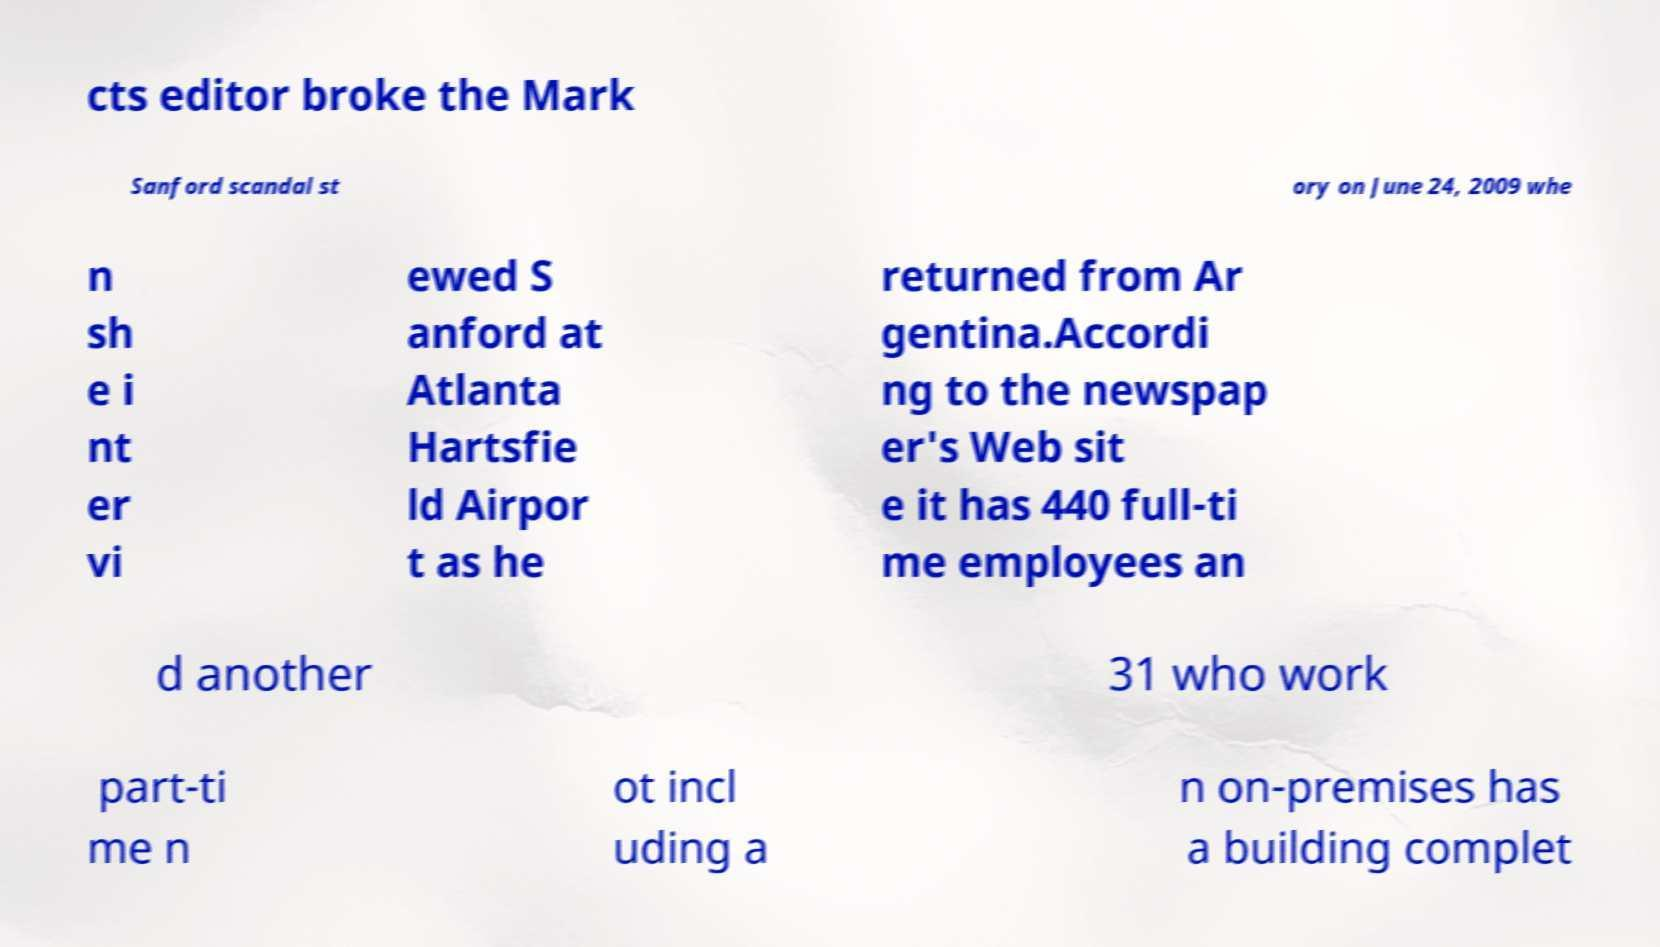Can you read and provide the text displayed in the image?This photo seems to have some interesting text. Can you extract and type it out for me? cts editor broke the Mark Sanford scandal st ory on June 24, 2009 whe n sh e i nt er vi ewed S anford at Atlanta Hartsfie ld Airpor t as he returned from Ar gentina.Accordi ng to the newspap er's Web sit e it has 440 full-ti me employees an d another 31 who work part-ti me n ot incl uding a n on-premises has a building complet 